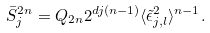<formula> <loc_0><loc_0><loc_500><loc_500>\bar { S } ^ { 2 n } _ { j } = Q _ { 2 n } 2 ^ { d j ( n - 1 ) } \langle \tilde { \epsilon } _ { j , l } ^ { 2 } \rangle ^ { n - 1 } .</formula> 